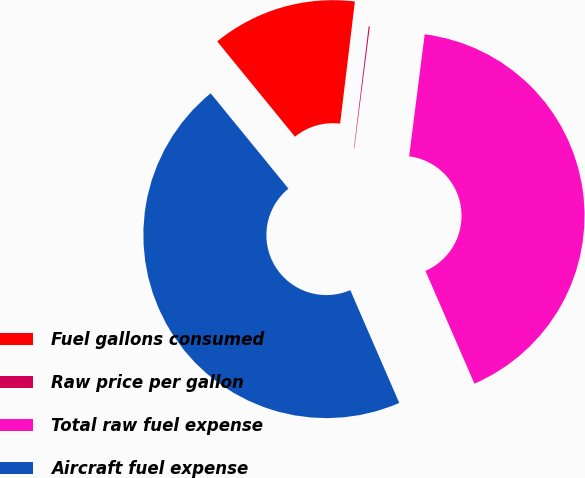Convert chart to OTSL. <chart><loc_0><loc_0><loc_500><loc_500><pie_chart><fcel>Fuel gallons consumed<fcel>Raw price per gallon<fcel>Total raw fuel expense<fcel>Aircraft fuel expense<nl><fcel>12.81%<fcel>0.1%<fcel>41.46%<fcel>45.62%<nl></chart> 